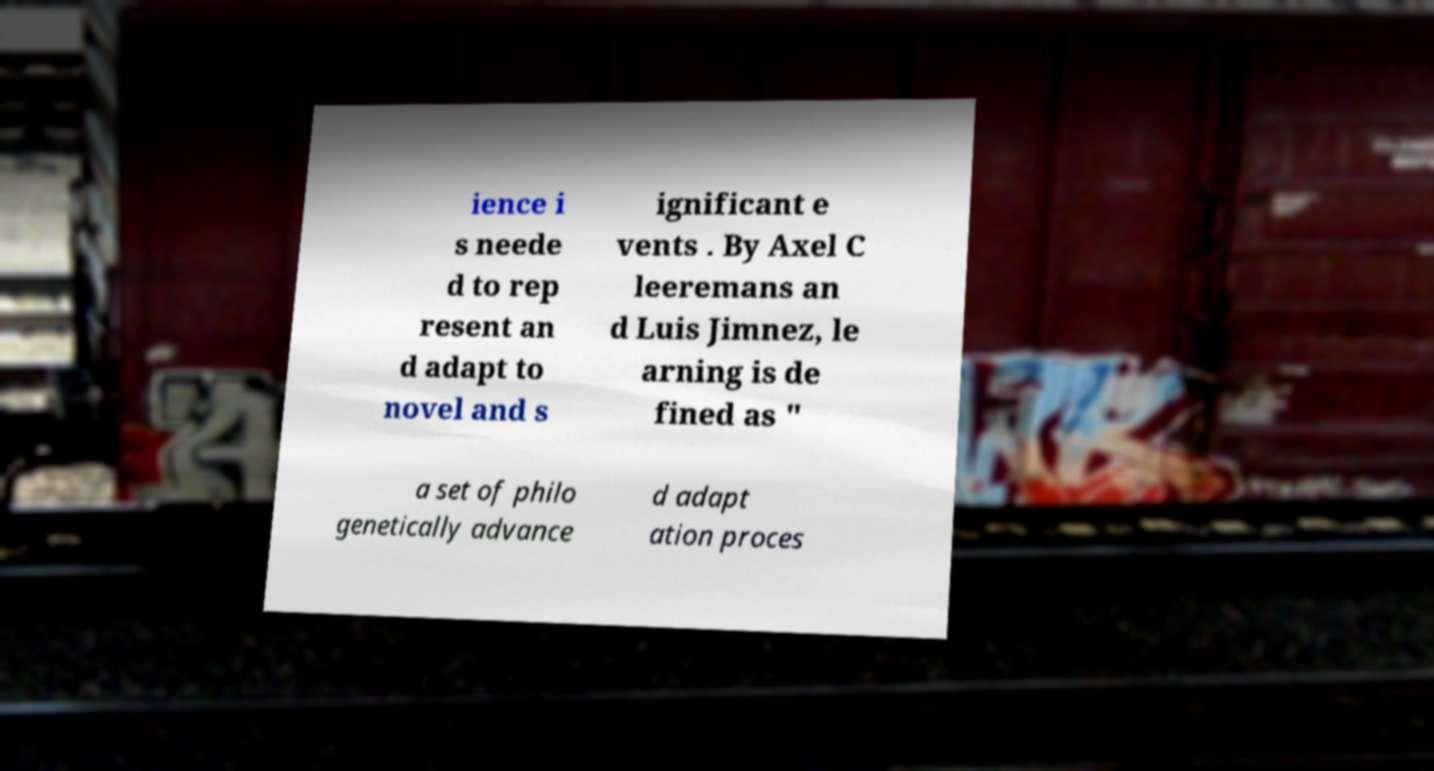What messages or text are displayed in this image? I need them in a readable, typed format. ience i s neede d to rep resent an d adapt to novel and s ignificant e vents . By Axel C leeremans an d Luis Jimnez, le arning is de fined as " a set of philo genetically advance d adapt ation proces 